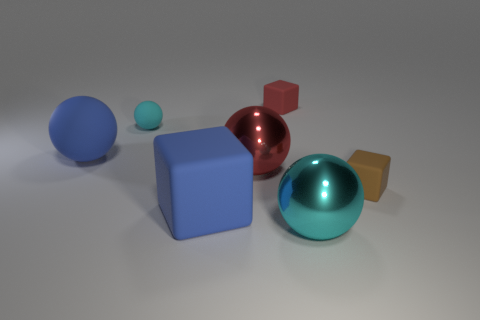Does the big blue object that is behind the brown matte object have the same material as the big red ball?
Your answer should be very brief. No. Are there fewer objects in front of the tiny cyan object than large cyan metallic objects right of the large cyan ball?
Ensure brevity in your answer.  No. Is there anything else that has the same shape as the small brown thing?
Keep it short and to the point. Yes. There is a object that is the same color as the tiny ball; what material is it?
Ensure brevity in your answer.  Metal. There is a tiny rubber thing on the right side of the cyan sphere to the right of the red rubber thing; how many cyan matte spheres are behind it?
Offer a terse response. 1. What number of big cyan objects are on the left side of the large cyan shiny ball?
Ensure brevity in your answer.  0. How many big cyan objects have the same material as the red ball?
Keep it short and to the point. 1. There is a big sphere that is the same material as the big blue cube; what is its color?
Provide a succinct answer. Blue. What is the material of the big sphere to the right of the small block that is behind the big blue thing behind the small brown cube?
Give a very brief answer. Metal. There is a matte thing that is right of the cyan shiny sphere; is it the same size as the small matte ball?
Your answer should be very brief. Yes. 